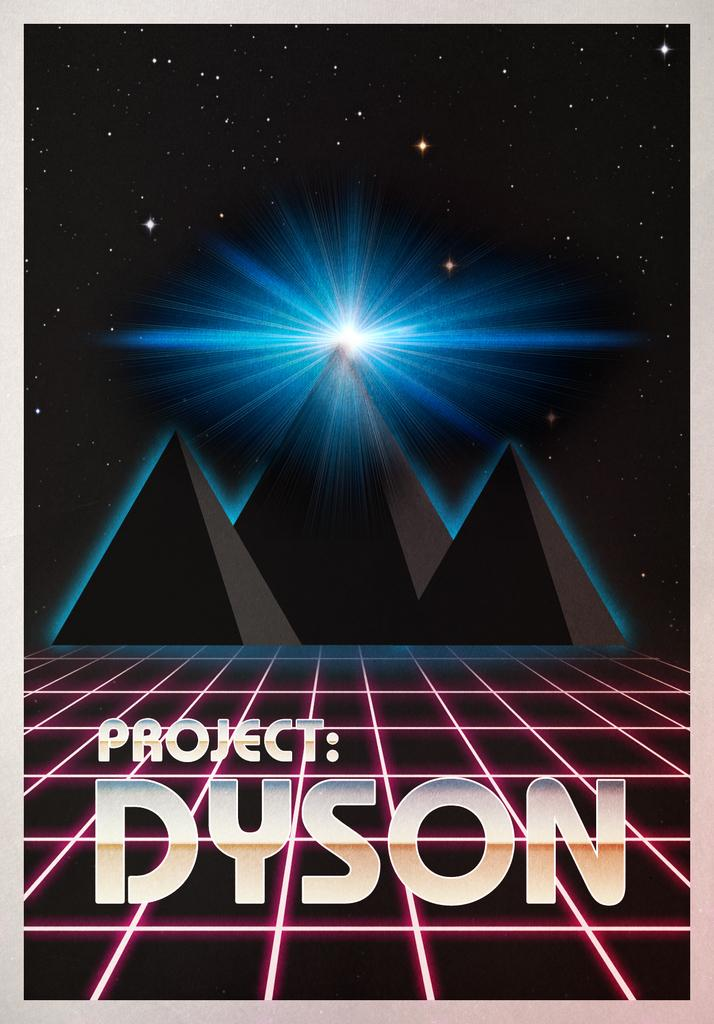Provide a one-sentence caption for the provided image. A poster for Project: Dyson showing an animated mountain range. 